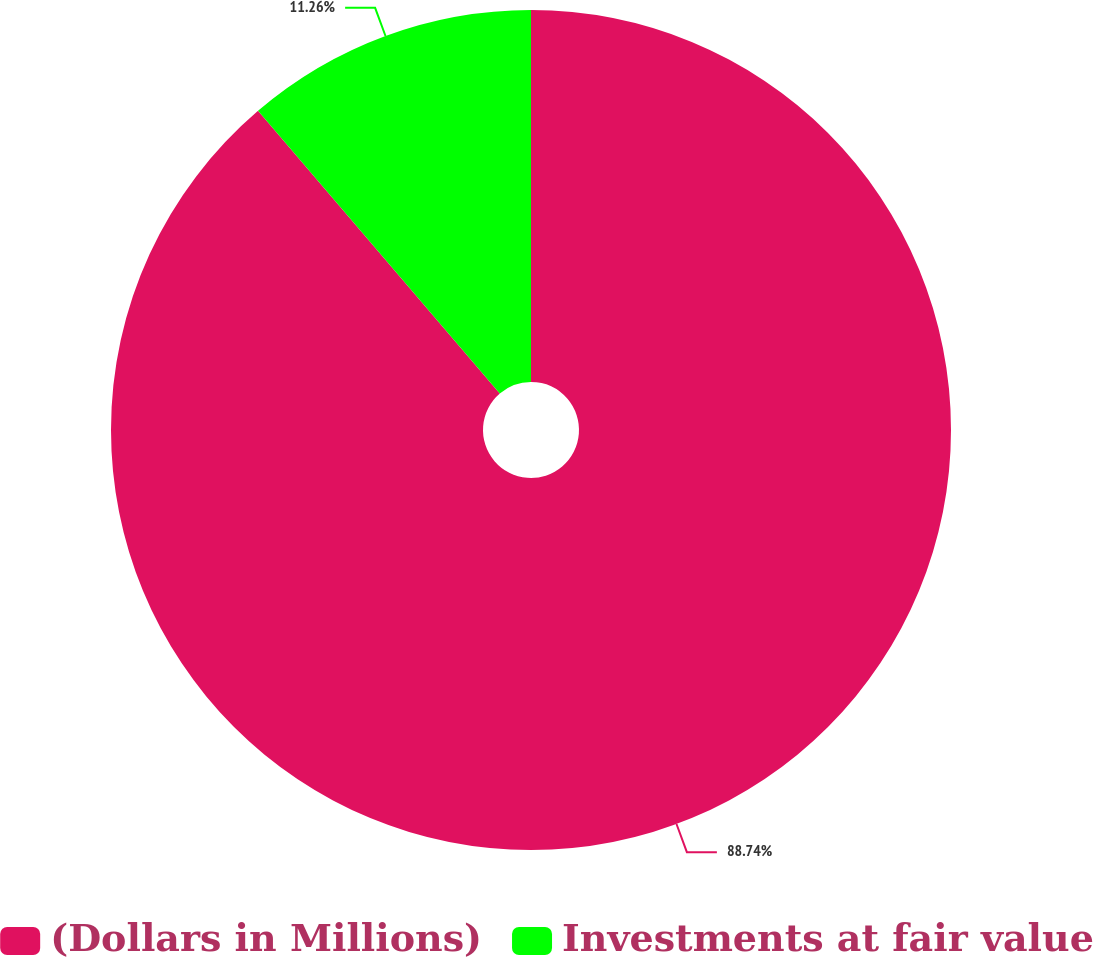Convert chart to OTSL. <chart><loc_0><loc_0><loc_500><loc_500><pie_chart><fcel>(Dollars in Millions)<fcel>Investments at fair value<nl><fcel>88.74%<fcel>11.26%<nl></chart> 